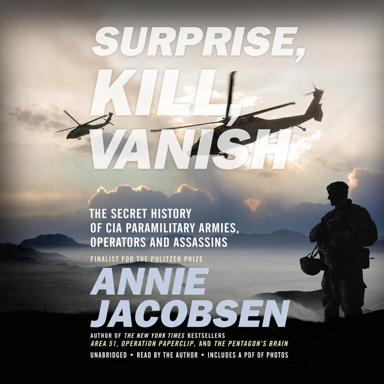Can you describe the setting depicted on the cover of the book? The cover features a dramatic silhouette of a lone soldier set against a backdrop of a dimly lit sky with helicopters and jet aircraft. This imagery suggests a setting of military operations, which aligns with the book's theme of CIA paramilitary activities. 